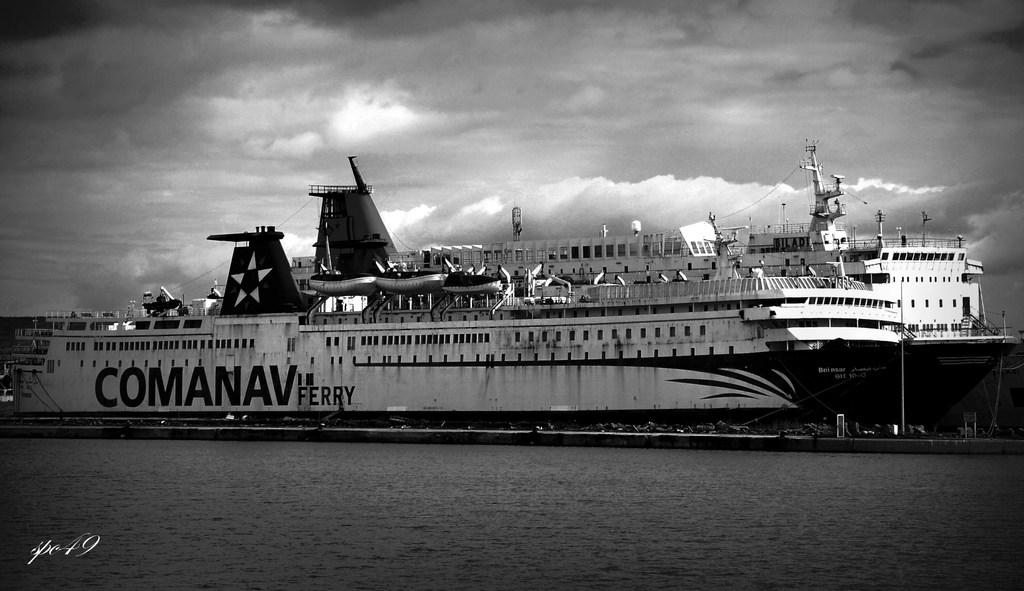Provide a one-sentence caption for the provided image. A picture of a ship at dock labeled Comanav Ferry. 